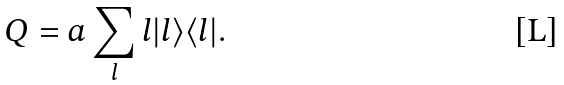<formula> <loc_0><loc_0><loc_500><loc_500>Q = a \sum _ { l } l | l \rangle \langle l | .</formula> 